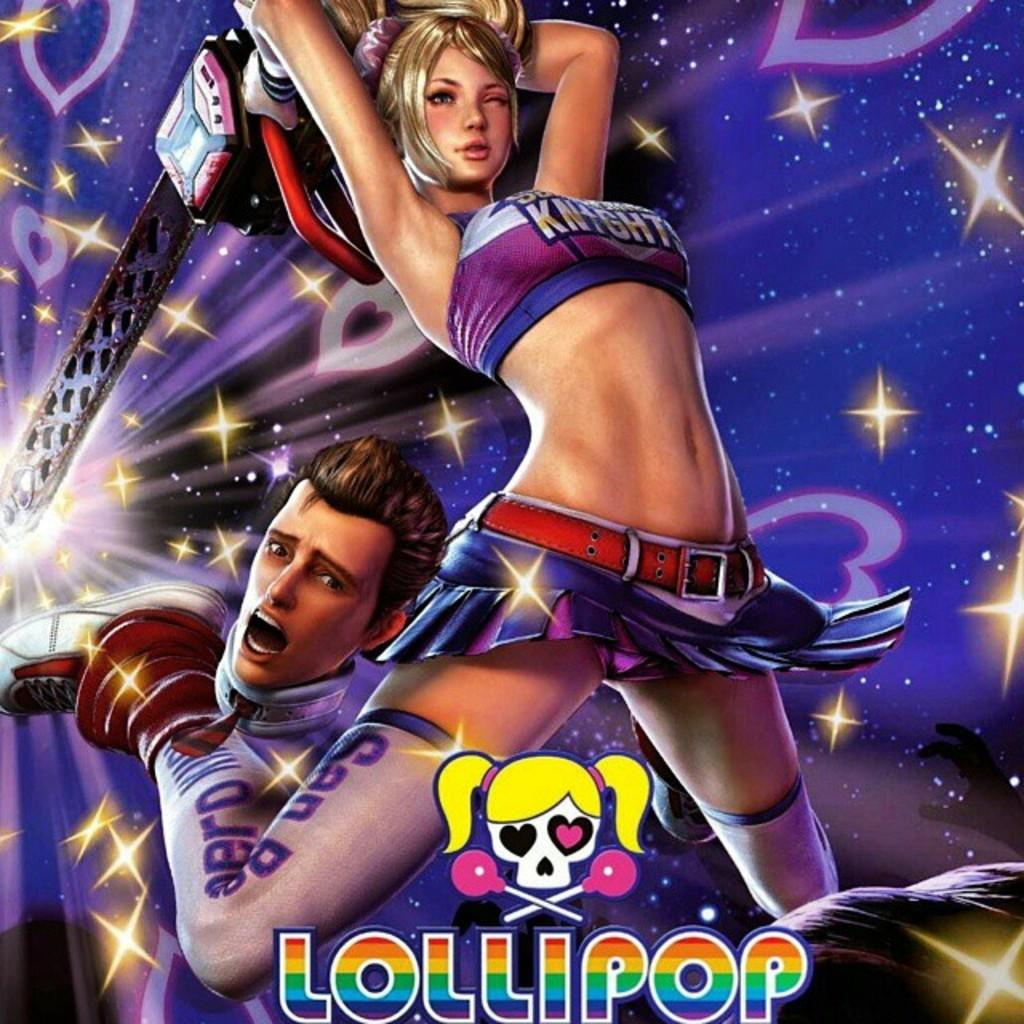Provide a one-sentence caption for the provided image. Lollipop comic drawing with a man and girl on the front. 